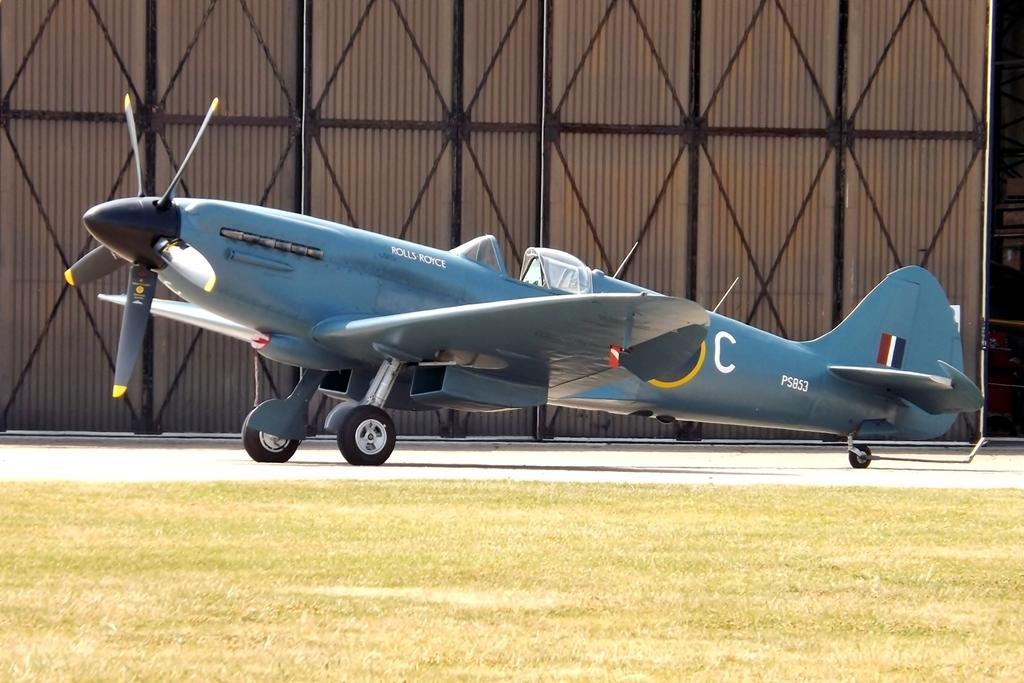Can you describe this image briefly? In this image we can see an airplane on the road. Here we can see grass. In the background we can see wall, poles, and rods. 